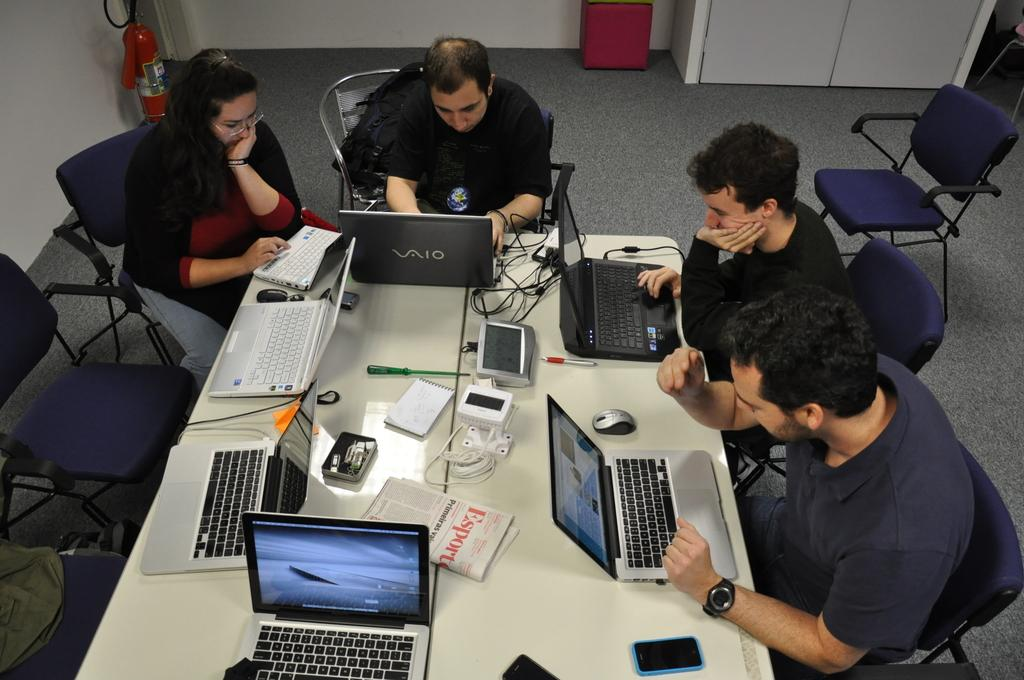<image>
Relay a brief, clear account of the picture shown. People using laptops with a newspaper that says "ESport" in between. 